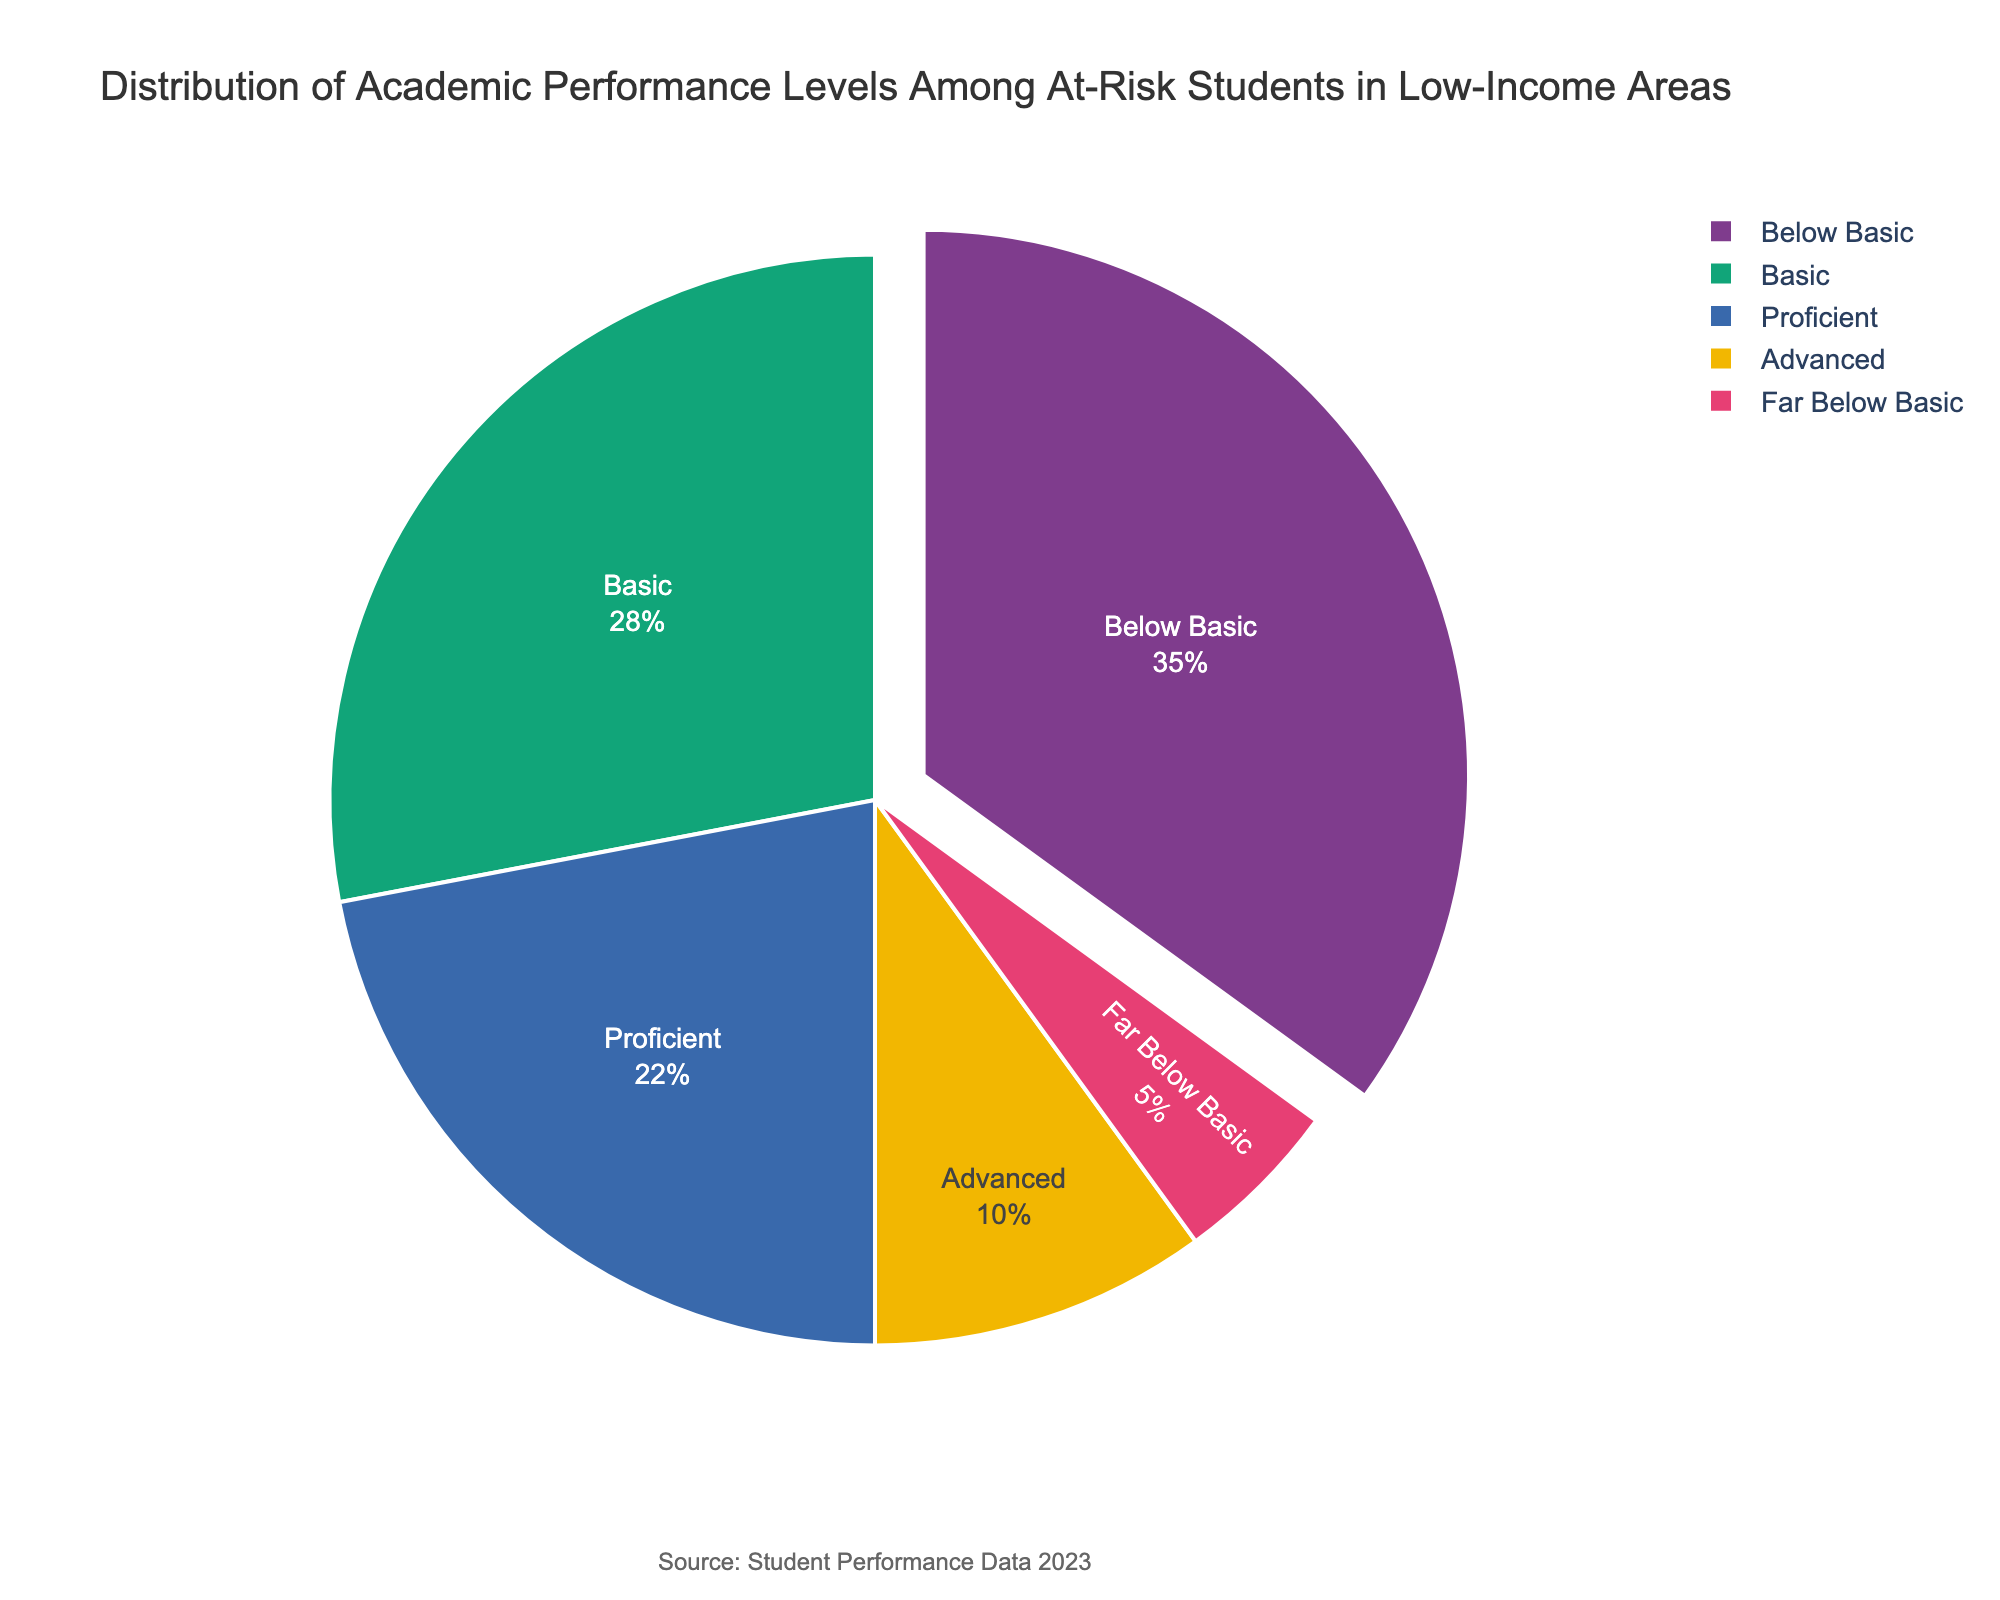What percentage of students performs at the "Below Basic" level? Locate the "Below Basic" slice in the pie chart, which represents 35% of the students.
Answer: 35% What is the combined percentage of students performing at "Basic" and "Proficient" levels? Sum the percentages for "Basic" (28%) and "Proficient" (22%): 28% + 22% = 50%.
Answer: 50% Which performance level has the least percentage of students? Identify the smallest slice in the pie chart, which is "Far Below Basic" at 5%.
Answer: Far Below Basic How much higher is the percentage of "Below Basic" compared to "Advanced"? Subtract the percentage of "Advanced" (10%) from the percentage of "Below Basic" (35%): 35% - 10% = 25%.
Answer: 25% What is the total percentage of students performing at "Below Basic", "Basic", and "Proficient" levels combined? Add the percentages for "Below Basic" (35%), "Basic" (28%), and "Proficient" (22%): 35% + 28% + 22% = 85%.
Answer: 85% What is the percentage difference between the highest and the lowest performance levels? Subtract the percentage of the lowest performance level "Far Below Basic" (5%) from the highest performance level "Below Basic" (35%): 35% - 5% = 30%.
Answer: 30% Which performance level pulls away from the pie chart? The slice that pulls away typically represents the largest percentage. Here, it is "Below Basic" with 35%.
Answer: Below Basic How many performance levels are displayed in the pie chart? Count the distinct segments or slices in the pie chart, which are five levels: "Below Basic", "Basic", "Proficient", "Advanced", and "Far Below Basic".
Answer: 5 If the "Far Below Basic" percentage is doubled, what would be the new combined percentage for "Far Below Basic" and "Advanced"? Double the "Far Below Basic" percentage: 5% * 2 = 10%. Add this to the "Advanced" percentage (10%): 10% + 10% = 20%.
Answer: 20% 